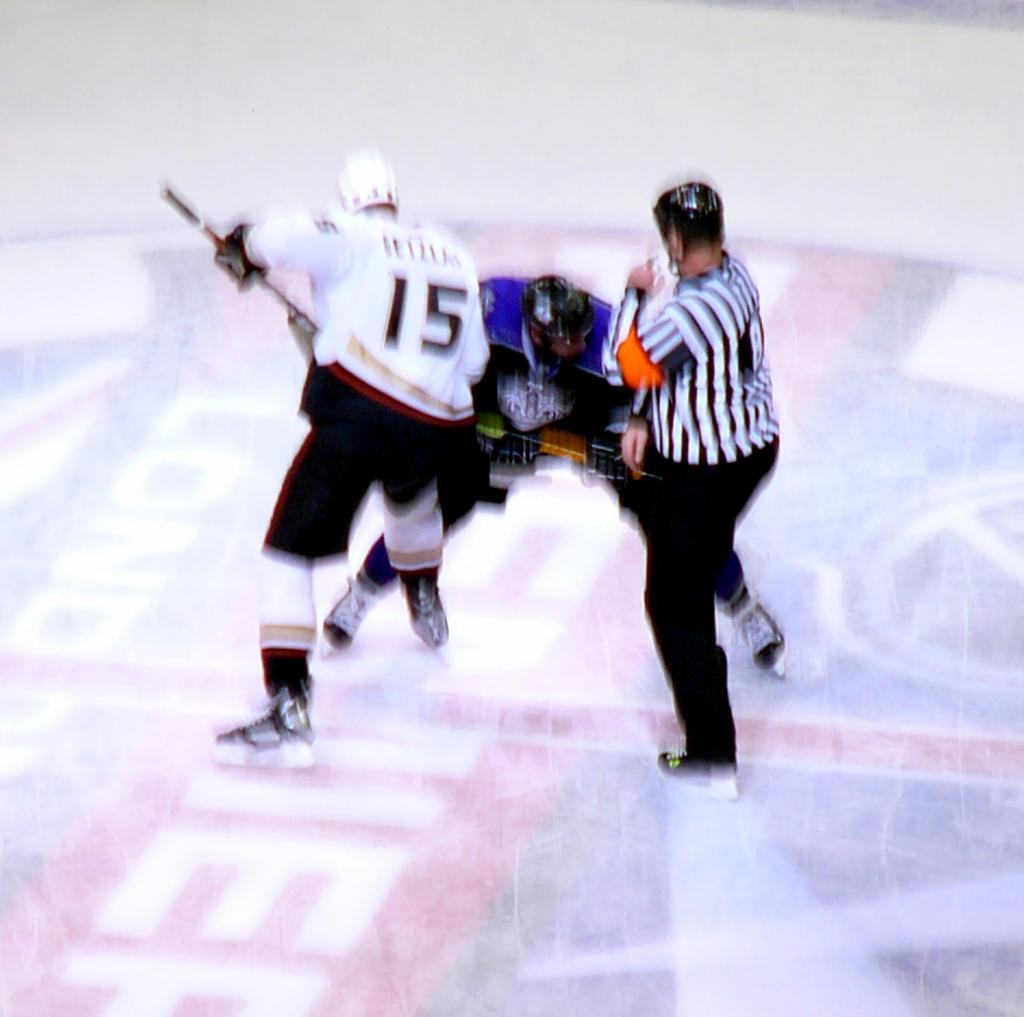How many people are in the image? There are three people in the image. What are the people wearing on their heads? The people are wearing helmets. What type of shoes are the people wearing? The people are wearing snow skiing shoes. What type of root can be seen growing from the person's helmet in the image? There is no root growing from any of the helmets in the image. What musical instrument is the person playing in the image? There is no musical instrument being played in the image. 